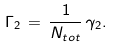<formula> <loc_0><loc_0><loc_500><loc_500>\Gamma _ { 2 } \, = \, \frac { 1 } { N _ { t o t } } \, \gamma _ { 2 } .</formula> 